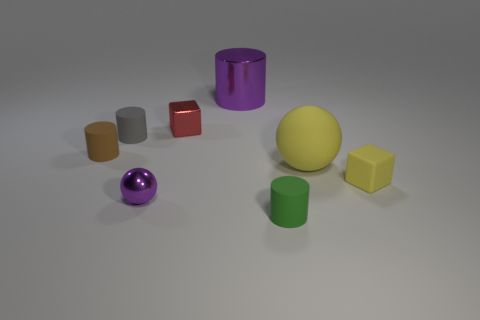Subtract all tiny cylinders. How many cylinders are left? 1 Add 1 big cyan matte spheres. How many objects exist? 9 Subtract all green cylinders. How many cylinders are left? 3 Subtract all cubes. How many objects are left? 6 Subtract all brown rubber things. Subtract all tiny purple metal objects. How many objects are left? 6 Add 8 small red things. How many small red things are left? 9 Add 4 small green metallic cylinders. How many small green metallic cylinders exist? 4 Subtract 0 red spheres. How many objects are left? 8 Subtract all purple spheres. Subtract all brown cylinders. How many spheres are left? 1 